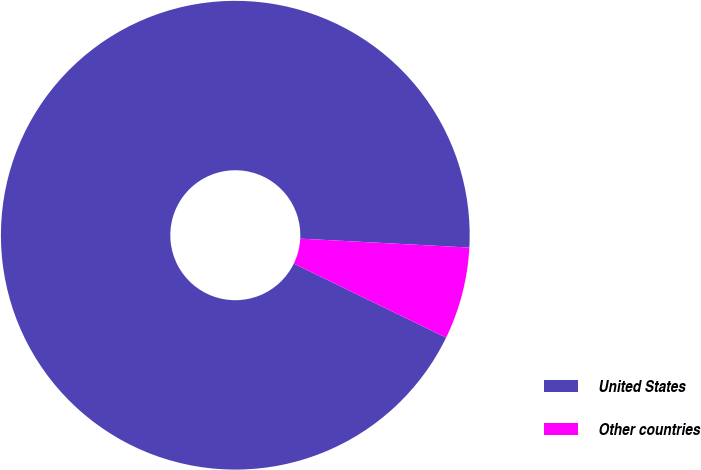Convert chart. <chart><loc_0><loc_0><loc_500><loc_500><pie_chart><fcel>United States<fcel>Other countries<nl><fcel>93.64%<fcel>6.36%<nl></chart> 